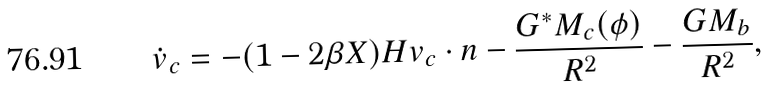<formula> <loc_0><loc_0><loc_500><loc_500>\dot { v } _ { c } = - ( 1 - 2 \beta X ) H { v } _ { c } \cdot { n } - \frac { G ^ { * } M _ { c } ( \phi ) } { R ^ { 2 } } - \frac { G M _ { b } } { R ^ { 2 } } ,</formula> 